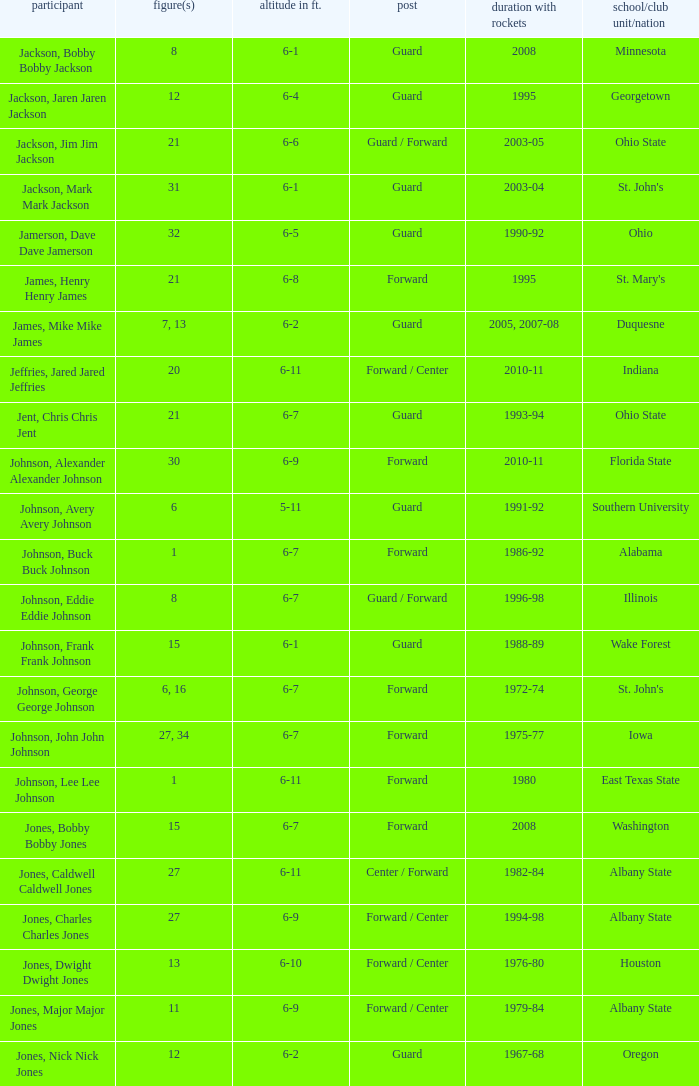How tall is the player jones, major major jones? 6-9. 